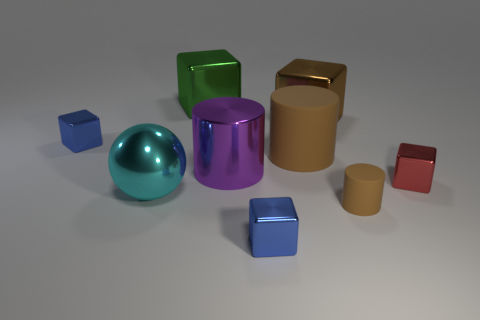Is the number of blue cubes on the left side of the big purple thing less than the number of tiny blue cubes?
Offer a terse response. Yes. How many large brown things are behind the big object to the right of the large brown cylinder?
Provide a succinct answer. 0. What is the size of the shiny thing that is both in front of the tiny red block and to the right of the large cyan shiny thing?
Provide a short and direct response. Small. Is there any other thing that is made of the same material as the big cyan ball?
Your answer should be very brief. Yes. Does the cyan ball have the same material as the blue cube that is in front of the big cyan sphere?
Make the answer very short. Yes. Is the number of big rubber objects that are in front of the red shiny thing less than the number of green metal cubes that are in front of the big green cube?
Offer a very short reply. No. There is a small block that is on the right side of the small cylinder; what is its material?
Your answer should be very brief. Metal. The small metal object that is behind the small brown rubber object and on the left side of the small brown cylinder is what color?
Make the answer very short. Blue. What number of other objects are there of the same color as the small rubber cylinder?
Provide a short and direct response. 2. There is a block in front of the cyan thing; what color is it?
Give a very brief answer. Blue. 